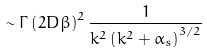Convert formula to latex. <formula><loc_0><loc_0><loc_500><loc_500>\sim \Gamma \left ( 2 D \beta \right ) ^ { 2 } \frac { 1 } { k ^ { 2 } \left ( k ^ { 2 } + \alpha _ { s } \right ) ^ { 3 / 2 } }</formula> 